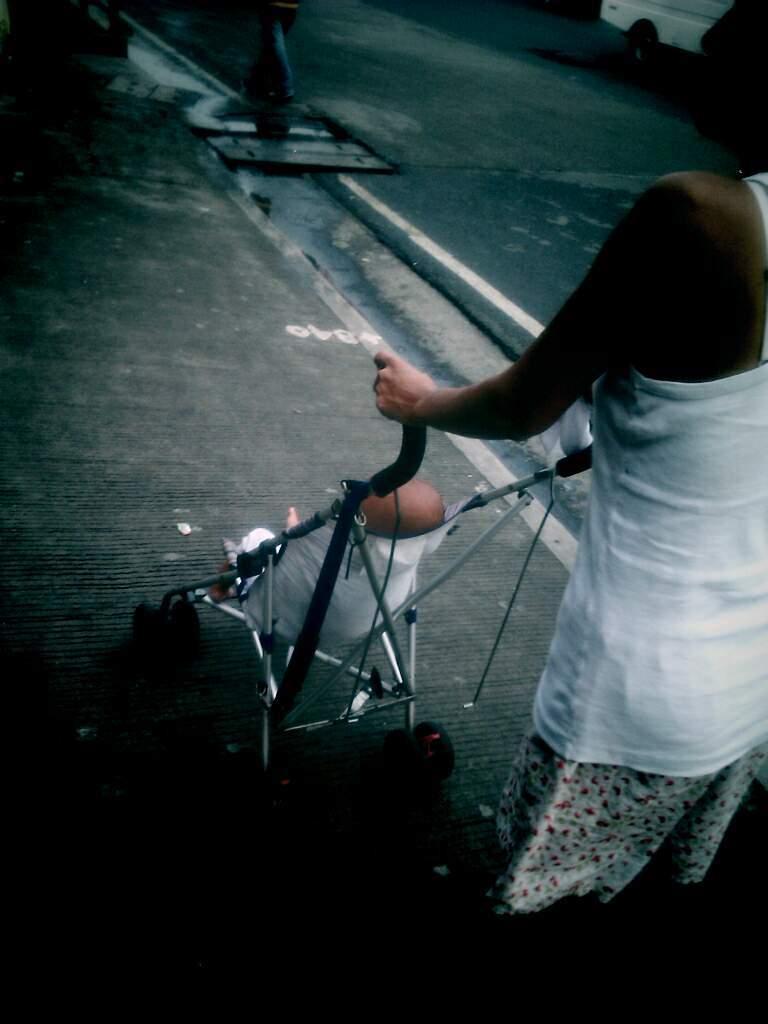Could you give a brief overview of what you see in this image? In the image in the center we can see one person standing and holding baby wheelchair. In wheelchair,we can see one baby. In the background there is a vehicle,road and few other objects. 